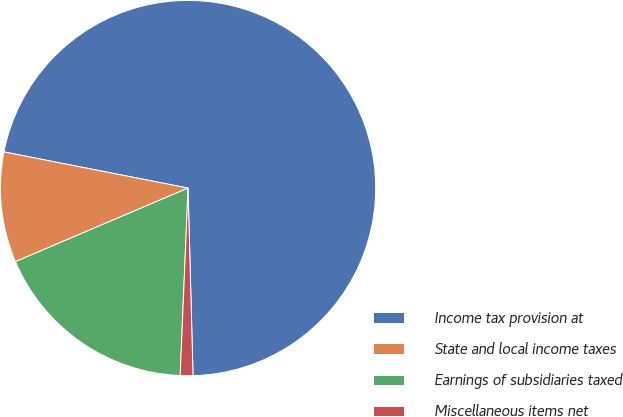Convert chart to OTSL. <chart><loc_0><loc_0><loc_500><loc_500><pie_chart><fcel>Income tax provision at<fcel>State and local income taxes<fcel>Earnings of subsidiaries taxed<fcel>Miscellaneous items net<nl><fcel>71.49%<fcel>9.5%<fcel>17.92%<fcel>1.09%<nl></chart> 